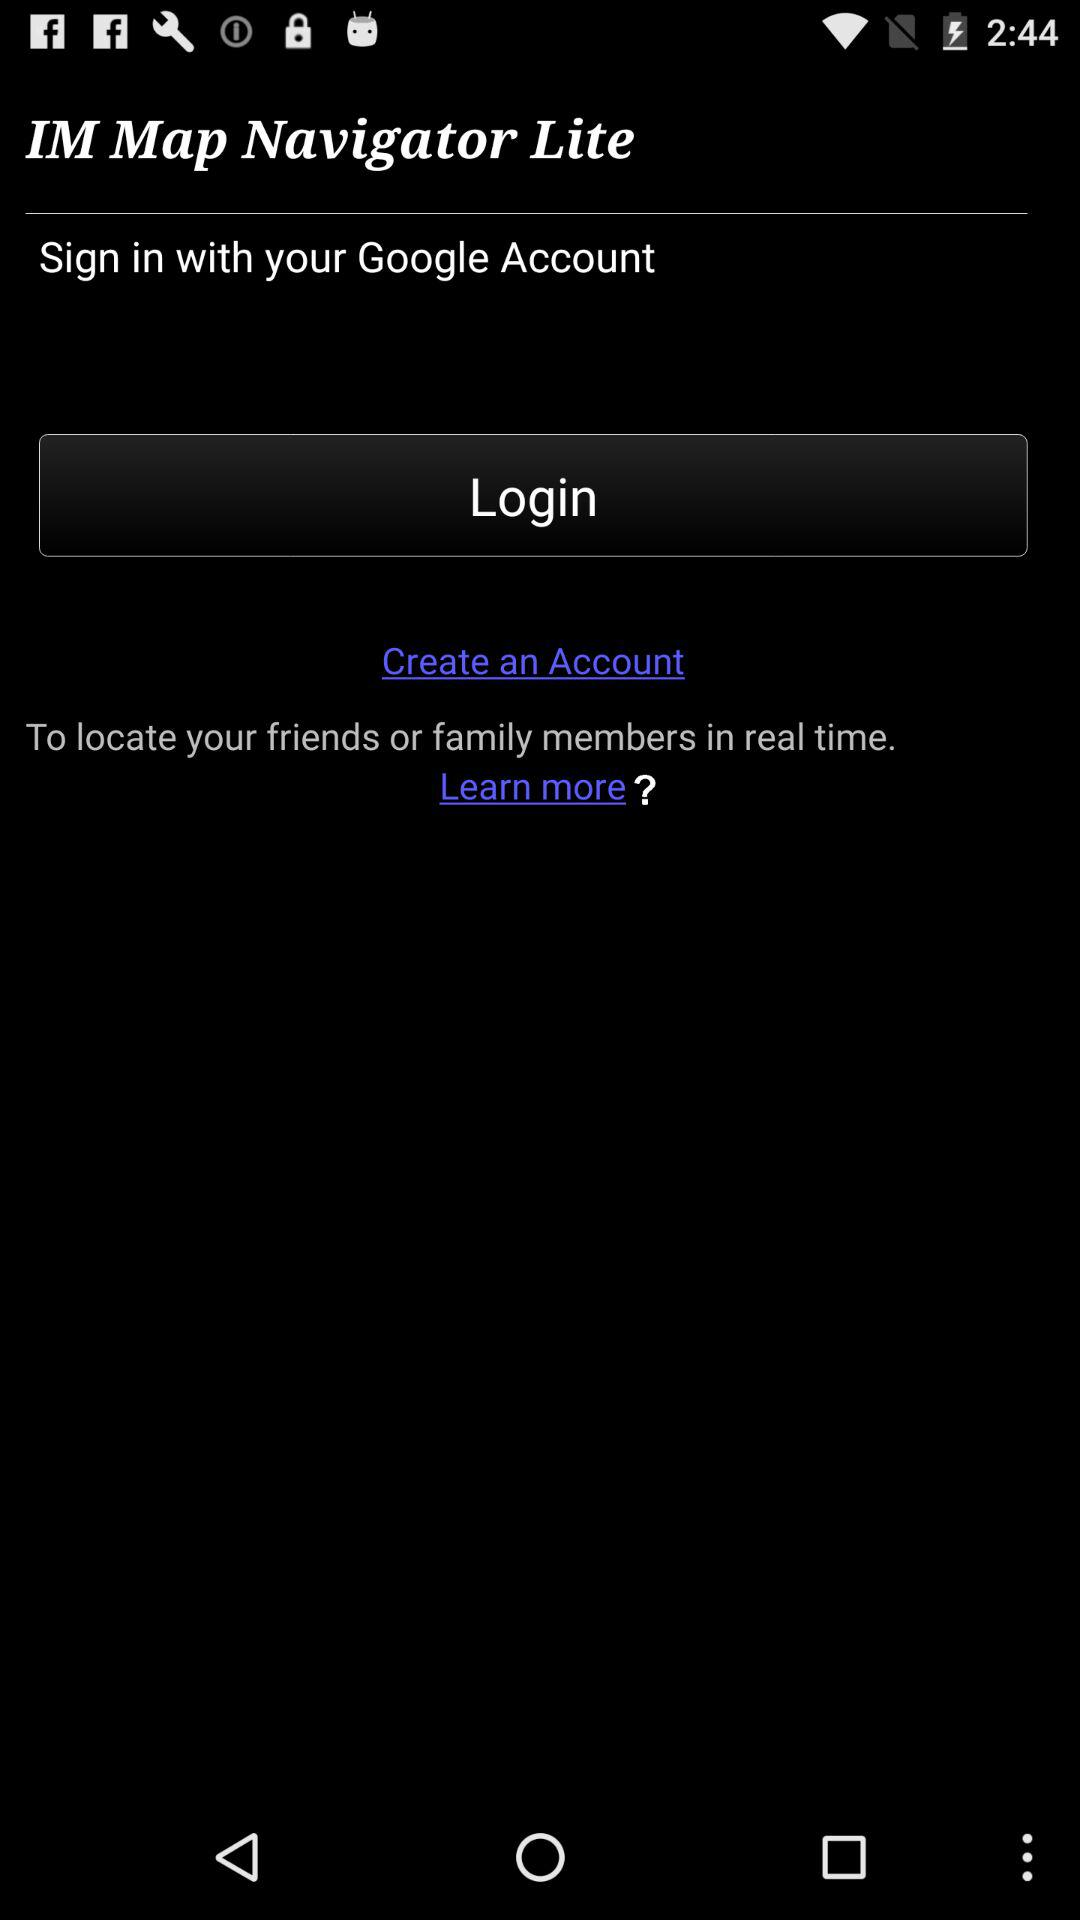What is the application name? The application name is "IM Map Navigator Lite". 